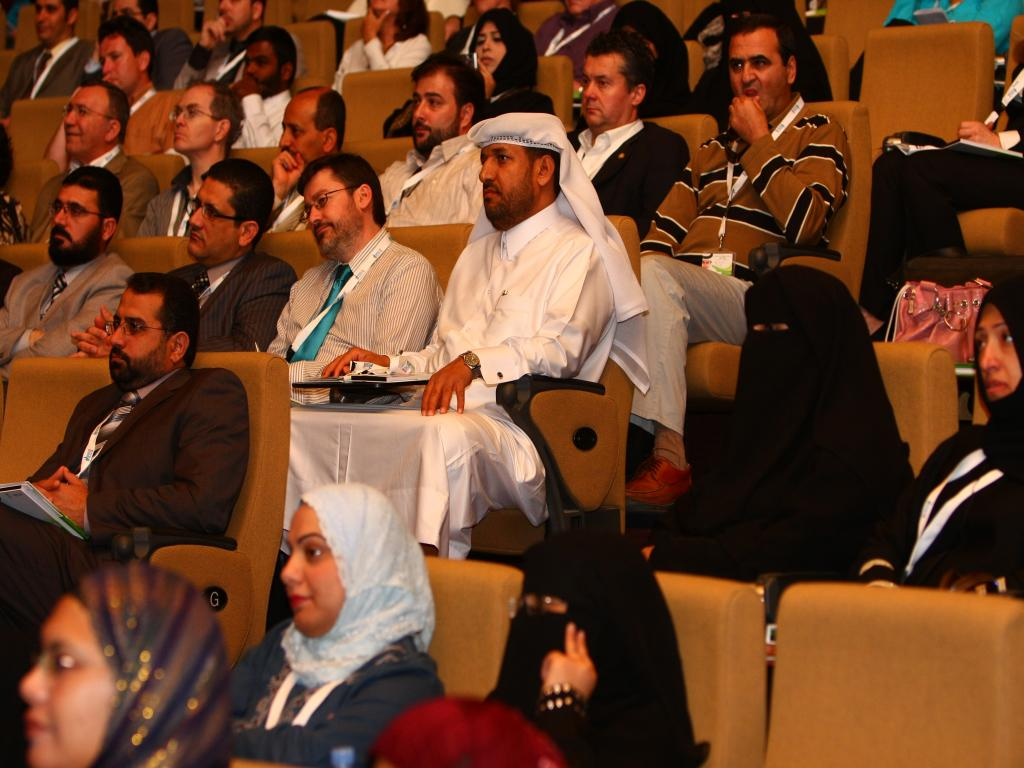Who or what can be seen in the image? There are people in the image. What are the people doing in the image? The people are sitting on chairs. What type of coal is being used to fuel the chairs in the image? There is no coal present in the image, and the chairs are not fueled by coal. 